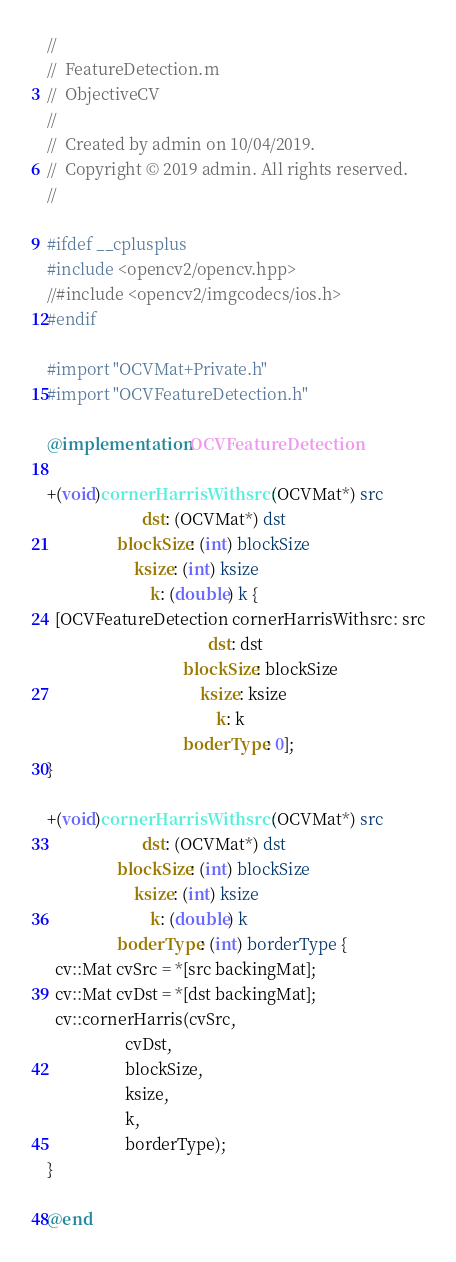<code> <loc_0><loc_0><loc_500><loc_500><_ObjectiveC_>//
//  FeatureDetection.m
//  ObjectiveCV
//
//  Created by admin on 10/04/2019.
//  Copyright © 2019 admin. All rights reserved.
//

#ifdef __cplusplus
#include <opencv2/opencv.hpp>
//#include <opencv2/imgcodecs/ios.h>
#endif

#import "OCVMat+Private.h"
#import "OCVFeatureDetection.h"

@implementation OCVFeatureDetection

+(void)cornerHarrisWithsrc: (OCVMat*) src
                       dst: (OCVMat*) dst
                 blockSize: (int) blockSize
                     ksize: (int) ksize
                         k: (double) k {
  [OCVFeatureDetection cornerHarrisWithsrc: src
                                       dst: dst
                                 blockSize: blockSize
                                     ksize: ksize
                                         k: k
                                 boderType: 0];
}

+(void)cornerHarrisWithsrc: (OCVMat*) src
                       dst: (OCVMat*) dst
                 blockSize: (int) blockSize
                     ksize: (int) ksize
                         k: (double) k
                 boderType: (int) borderType {
  cv::Mat cvSrc = *[src backingMat];
  cv::Mat cvDst = *[dst backingMat];
  cv::cornerHarris(cvSrc,
                   cvDst,
                   blockSize,
                   ksize,
                   k,
                   borderType);
}

@end
</code> 